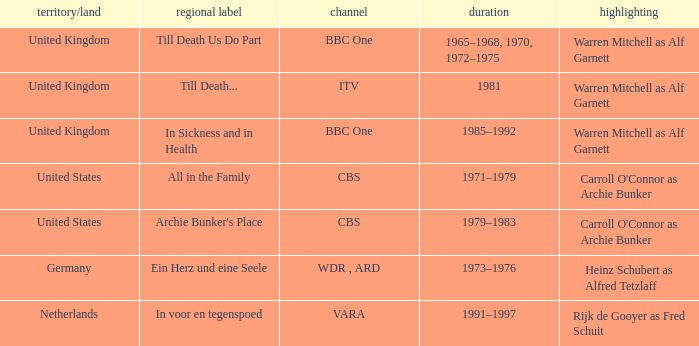What dates did the episodes air in the United States? 1971–1979, 1979–1983. 